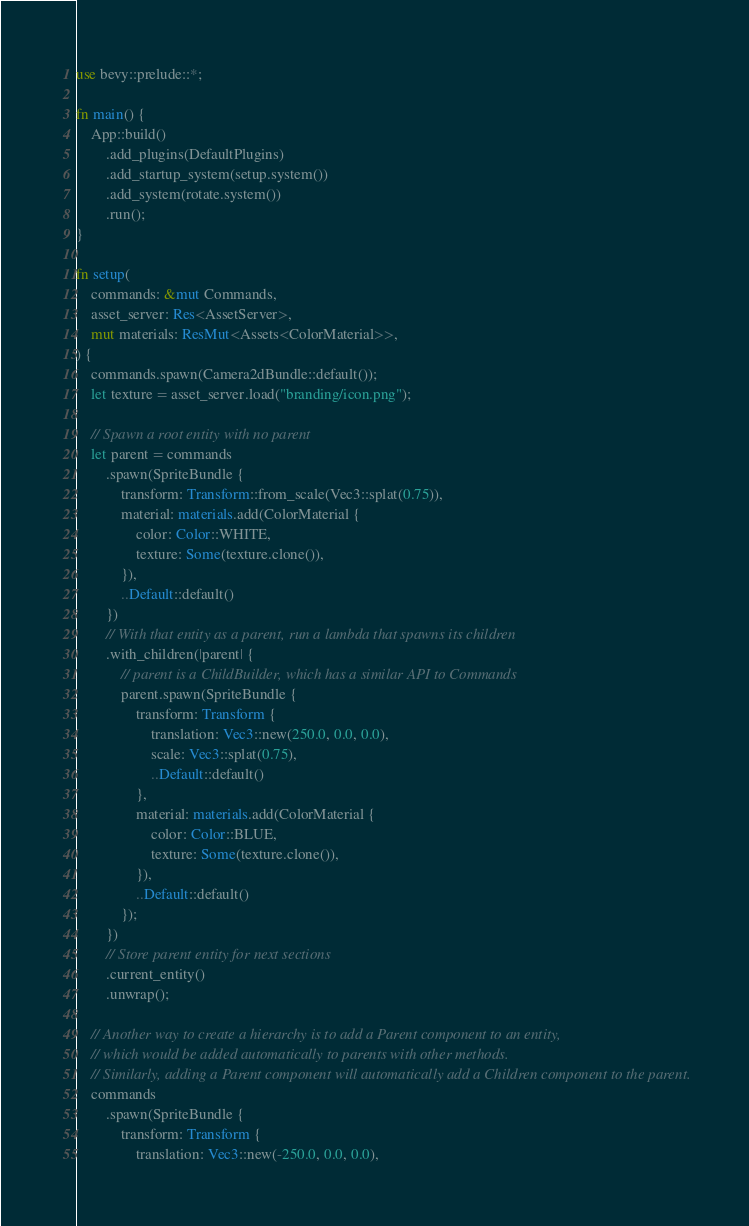Convert code to text. <code><loc_0><loc_0><loc_500><loc_500><_Rust_>use bevy::prelude::*;

fn main() {
    App::build()
        .add_plugins(DefaultPlugins)
        .add_startup_system(setup.system())
        .add_system(rotate.system())
        .run();
}

fn setup(
    commands: &mut Commands,
    asset_server: Res<AssetServer>,
    mut materials: ResMut<Assets<ColorMaterial>>,
) {
    commands.spawn(Camera2dBundle::default());
    let texture = asset_server.load("branding/icon.png");

    // Spawn a root entity with no parent
    let parent = commands
        .spawn(SpriteBundle {
            transform: Transform::from_scale(Vec3::splat(0.75)),
            material: materials.add(ColorMaterial {
                color: Color::WHITE,
                texture: Some(texture.clone()),
            }),
            ..Default::default()
        })
        // With that entity as a parent, run a lambda that spawns its children
        .with_children(|parent| {
            // parent is a ChildBuilder, which has a similar API to Commands
            parent.spawn(SpriteBundle {
                transform: Transform {
                    translation: Vec3::new(250.0, 0.0, 0.0),
                    scale: Vec3::splat(0.75),
                    ..Default::default()
                },
                material: materials.add(ColorMaterial {
                    color: Color::BLUE,
                    texture: Some(texture.clone()),
                }),
                ..Default::default()
            });
        })
        // Store parent entity for next sections
        .current_entity()
        .unwrap();

    // Another way to create a hierarchy is to add a Parent component to an entity,
    // which would be added automatically to parents with other methods.
    // Similarly, adding a Parent component will automatically add a Children component to the parent.
    commands
        .spawn(SpriteBundle {
            transform: Transform {
                translation: Vec3::new(-250.0, 0.0, 0.0),</code> 